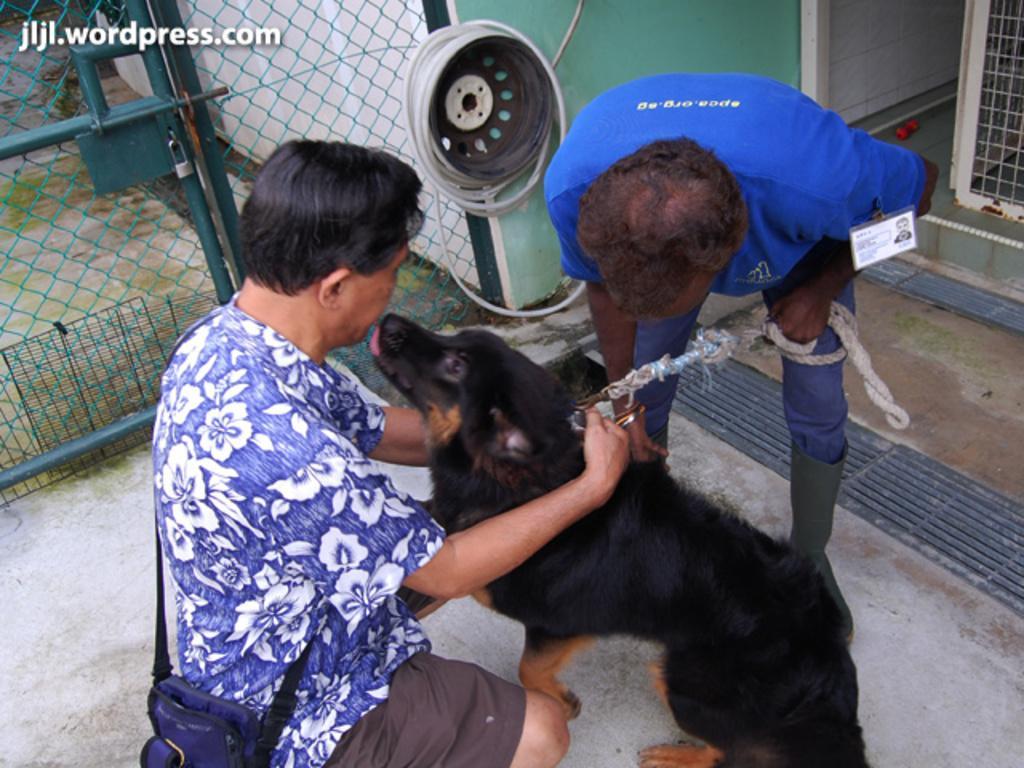Could you give a brief overview of what you see in this image? In this image we can see two persons and there is a dog and we can see a building in the background and there is a mesh door. We can see some text on the image. 